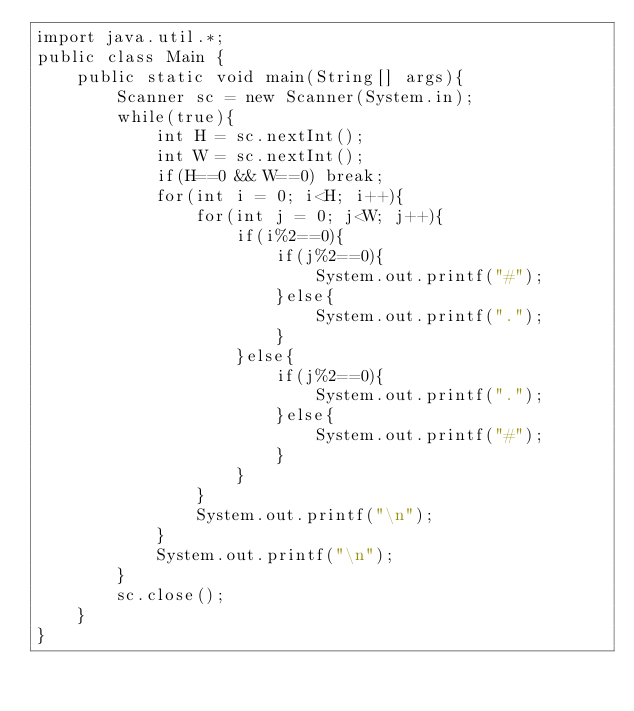Convert code to text. <code><loc_0><loc_0><loc_500><loc_500><_Java_>import java.util.*;
public class Main {
    public static void main(String[] args){
        Scanner sc = new Scanner(System.in);
        while(true){
            int H = sc.nextInt();
            int W = sc.nextInt();
            if(H==0 && W==0) break;
            for(int i = 0; i<H; i++){
                for(int j = 0; j<W; j++){
                    if(i%2==0){
                        if(j%2==0){
                            System.out.printf("#");
                        }else{
                            System.out.printf(".");
                        }
                    }else{
                        if(j%2==0){
                            System.out.printf(".");
                        }else{
                            System.out.printf("#");
                        }
                    }   
                }
                System.out.printf("\n");
            }
            System.out.printf("\n");
        }
        sc.close();
    }
}
</code> 